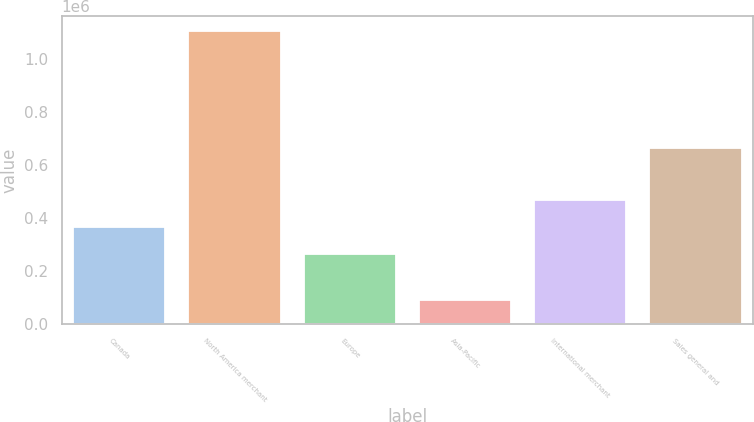Convert chart. <chart><loc_0><loc_0><loc_500><loc_500><bar_chart><fcel>Canada<fcel>North America merchant<fcel>Europe<fcel>Asia-Pacific<fcel>International merchant<fcel>Sales general and<nl><fcel>366773<fcel>1.10685e+06<fcel>265121<fcel>90334<fcel>468424<fcel>664905<nl></chart> 